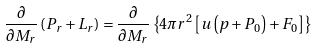Convert formula to latex. <formula><loc_0><loc_0><loc_500><loc_500>\frac { \partial } { \partial M _ { r } } \left ( P _ { r } + L _ { r } \right ) = \frac { \partial } { \partial M _ { r } } \left \{ 4 \pi r ^ { 2 } \left [ u \left ( p + P _ { 0 } \right ) + F _ { 0 } \right ] \right \}</formula> 